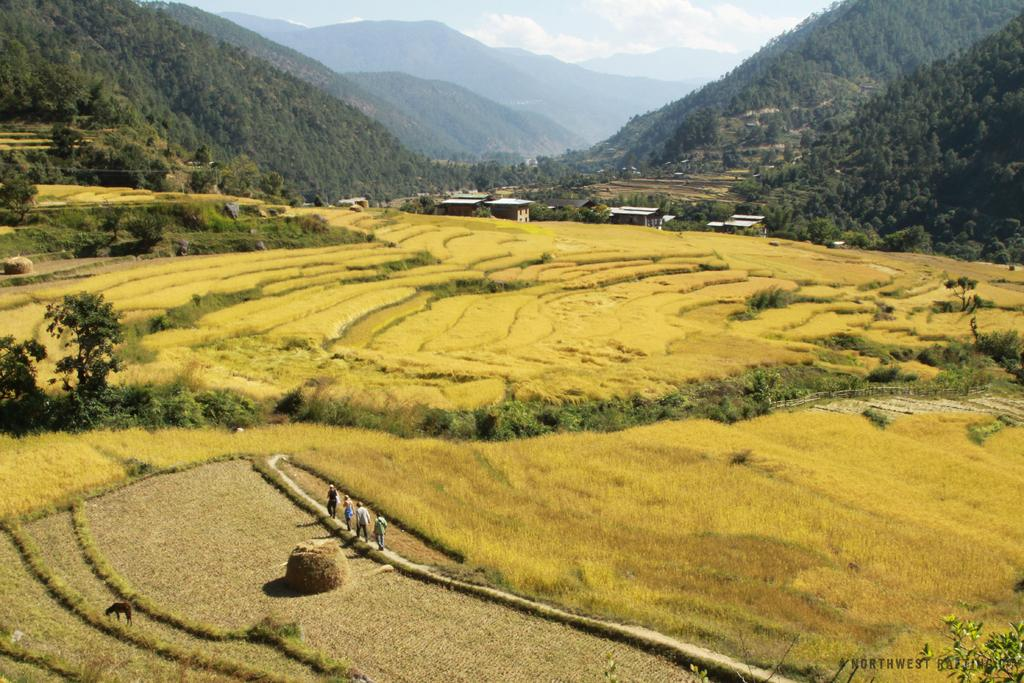What are the people in the image doing? The people in the image are on a path. What can be seen beside the path? There are fields beside the path. What type of vegetation is present in the image? There are trees in the image. What structures can be seen in the background of the image? There are sheds and mountains in the background of the image. What is visible in the sky in the image? The sky is visible in the background of the image, and clouds are present. How does the wind affect the people walking on the path in the image? There is no mention of wind in the image, so we cannot determine its effect on the people walking on the path. What type of skate is being used by the people in the image? There is no skate present in the image; the people are on a path. 